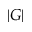Convert formula to latex. <formula><loc_0><loc_0><loc_500><loc_500>| G |</formula> 